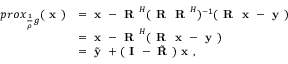<formula> <loc_0><loc_0><loc_500><loc_500>\begin{array} { r l } { p r o x _ { \frac { 1 } { \rho } g } ( x ) } & { = x - R ^ { H } ( R R ^ { H } ) ^ { - 1 } ( R x - y ) } \\ & { = x - R ^ { H } ( R x - y ) } \\ & { = \tilde { y } + ( I - \tilde { R } ) x , } \end{array}</formula> 